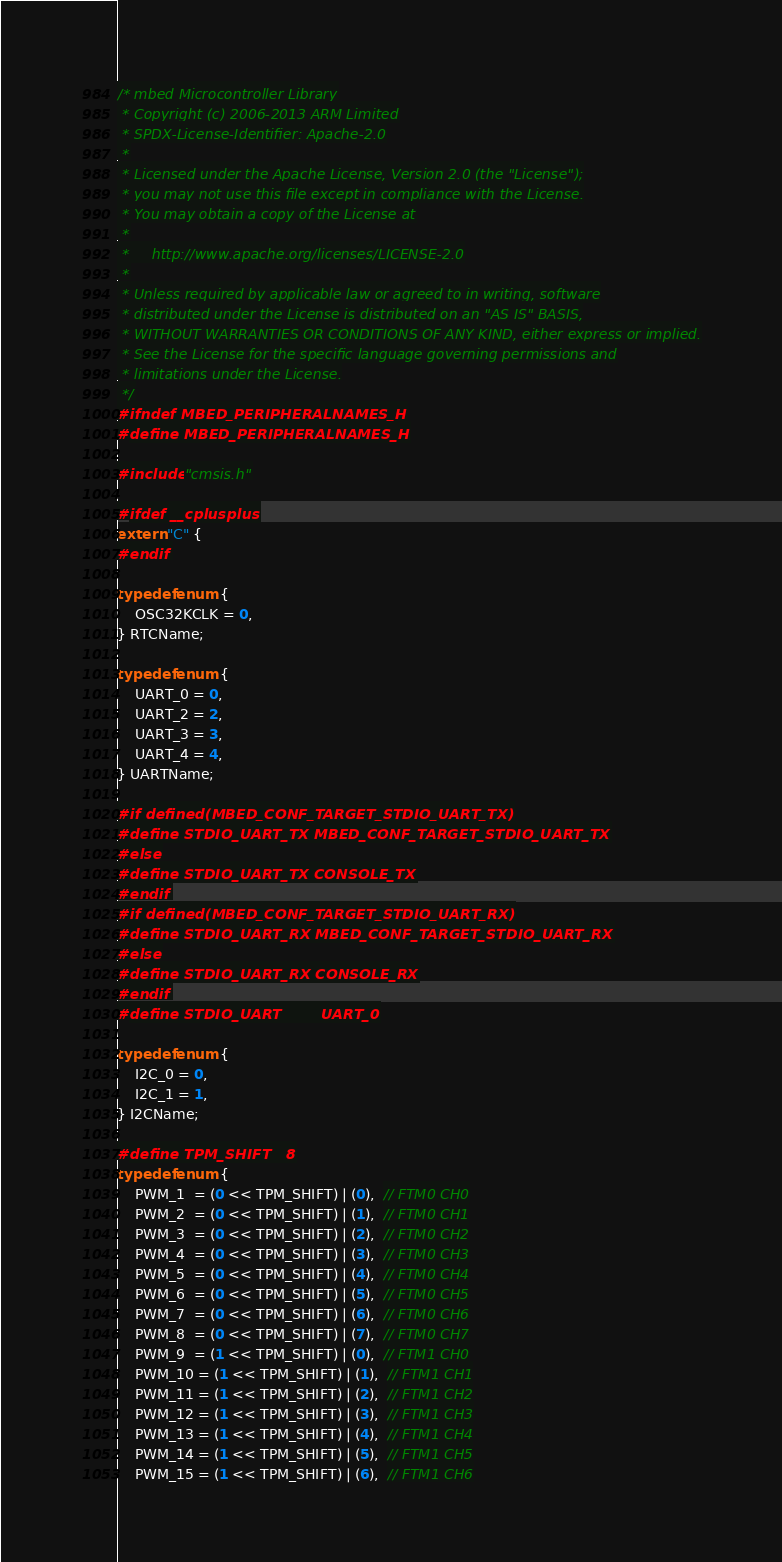<code> <loc_0><loc_0><loc_500><loc_500><_C_>/* mbed Microcontroller Library
 * Copyright (c) 2006-2013 ARM Limited
 * SPDX-License-Identifier: Apache-2.0
 *
 * Licensed under the Apache License, Version 2.0 (the "License");
 * you may not use this file except in compliance with the License.
 * You may obtain a copy of the License at
 *
 *     http://www.apache.org/licenses/LICENSE-2.0
 *
 * Unless required by applicable law or agreed to in writing, software
 * distributed under the License is distributed on an "AS IS" BASIS,
 * WITHOUT WARRANTIES OR CONDITIONS OF ANY KIND, either express or implied.
 * See the License for the specific language governing permissions and
 * limitations under the License.
 */
#ifndef MBED_PERIPHERALNAMES_H
#define MBED_PERIPHERALNAMES_H

#include "cmsis.h"

#ifdef __cplusplus
extern "C" {
#endif

typedef enum {
    OSC32KCLK = 0,
} RTCName;

typedef enum {
    UART_0 = 0,
    UART_2 = 2,
    UART_3 = 3,
    UART_4 = 4,
} UARTName;

#if defined(MBED_CONF_TARGET_STDIO_UART_TX)
#define STDIO_UART_TX MBED_CONF_TARGET_STDIO_UART_TX
#else
#define STDIO_UART_TX CONSOLE_TX
#endif
#if defined(MBED_CONF_TARGET_STDIO_UART_RX)
#define STDIO_UART_RX MBED_CONF_TARGET_STDIO_UART_RX
#else
#define STDIO_UART_RX CONSOLE_RX
#endif
#define STDIO_UART        UART_0

typedef enum {
    I2C_0 = 0,
    I2C_1 = 1,
} I2CName;

#define TPM_SHIFT   8
typedef enum {
    PWM_1  = (0 << TPM_SHIFT) | (0),  // FTM0 CH0
    PWM_2  = (0 << TPM_SHIFT) | (1),  // FTM0 CH1
    PWM_3  = (0 << TPM_SHIFT) | (2),  // FTM0 CH2
    PWM_4  = (0 << TPM_SHIFT) | (3),  // FTM0 CH3
    PWM_5  = (0 << TPM_SHIFT) | (4),  // FTM0 CH4
    PWM_6  = (0 << TPM_SHIFT) | (5),  // FTM0 CH5
    PWM_7  = (0 << TPM_SHIFT) | (6),  // FTM0 CH6
    PWM_8  = (0 << TPM_SHIFT) | (7),  // FTM0 CH7
    PWM_9  = (1 << TPM_SHIFT) | (0),  // FTM1 CH0
    PWM_10 = (1 << TPM_SHIFT) | (1),  // FTM1 CH1
    PWM_11 = (1 << TPM_SHIFT) | (2),  // FTM1 CH2
    PWM_12 = (1 << TPM_SHIFT) | (3),  // FTM1 CH3
    PWM_13 = (1 << TPM_SHIFT) | (4),  // FTM1 CH4
    PWM_14 = (1 << TPM_SHIFT) | (5),  // FTM1 CH5
    PWM_15 = (1 << TPM_SHIFT) | (6),  // FTM1 CH6</code> 